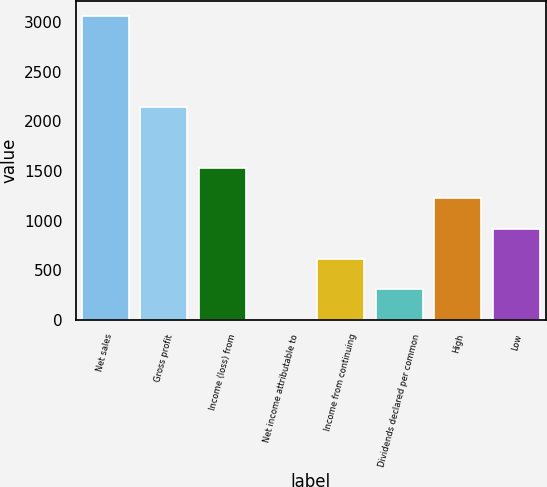<chart> <loc_0><loc_0><loc_500><loc_500><bar_chart><fcel>Net sales<fcel>Gross profit<fcel>Income (loss) from<fcel>Net income attributable to<fcel>Income from continuing<fcel>Dividends declared per common<fcel>High<fcel>Low<nl><fcel>3062.5<fcel>2143.81<fcel>1531.35<fcel>0.2<fcel>612.66<fcel>306.43<fcel>1225.12<fcel>918.89<nl></chart> 